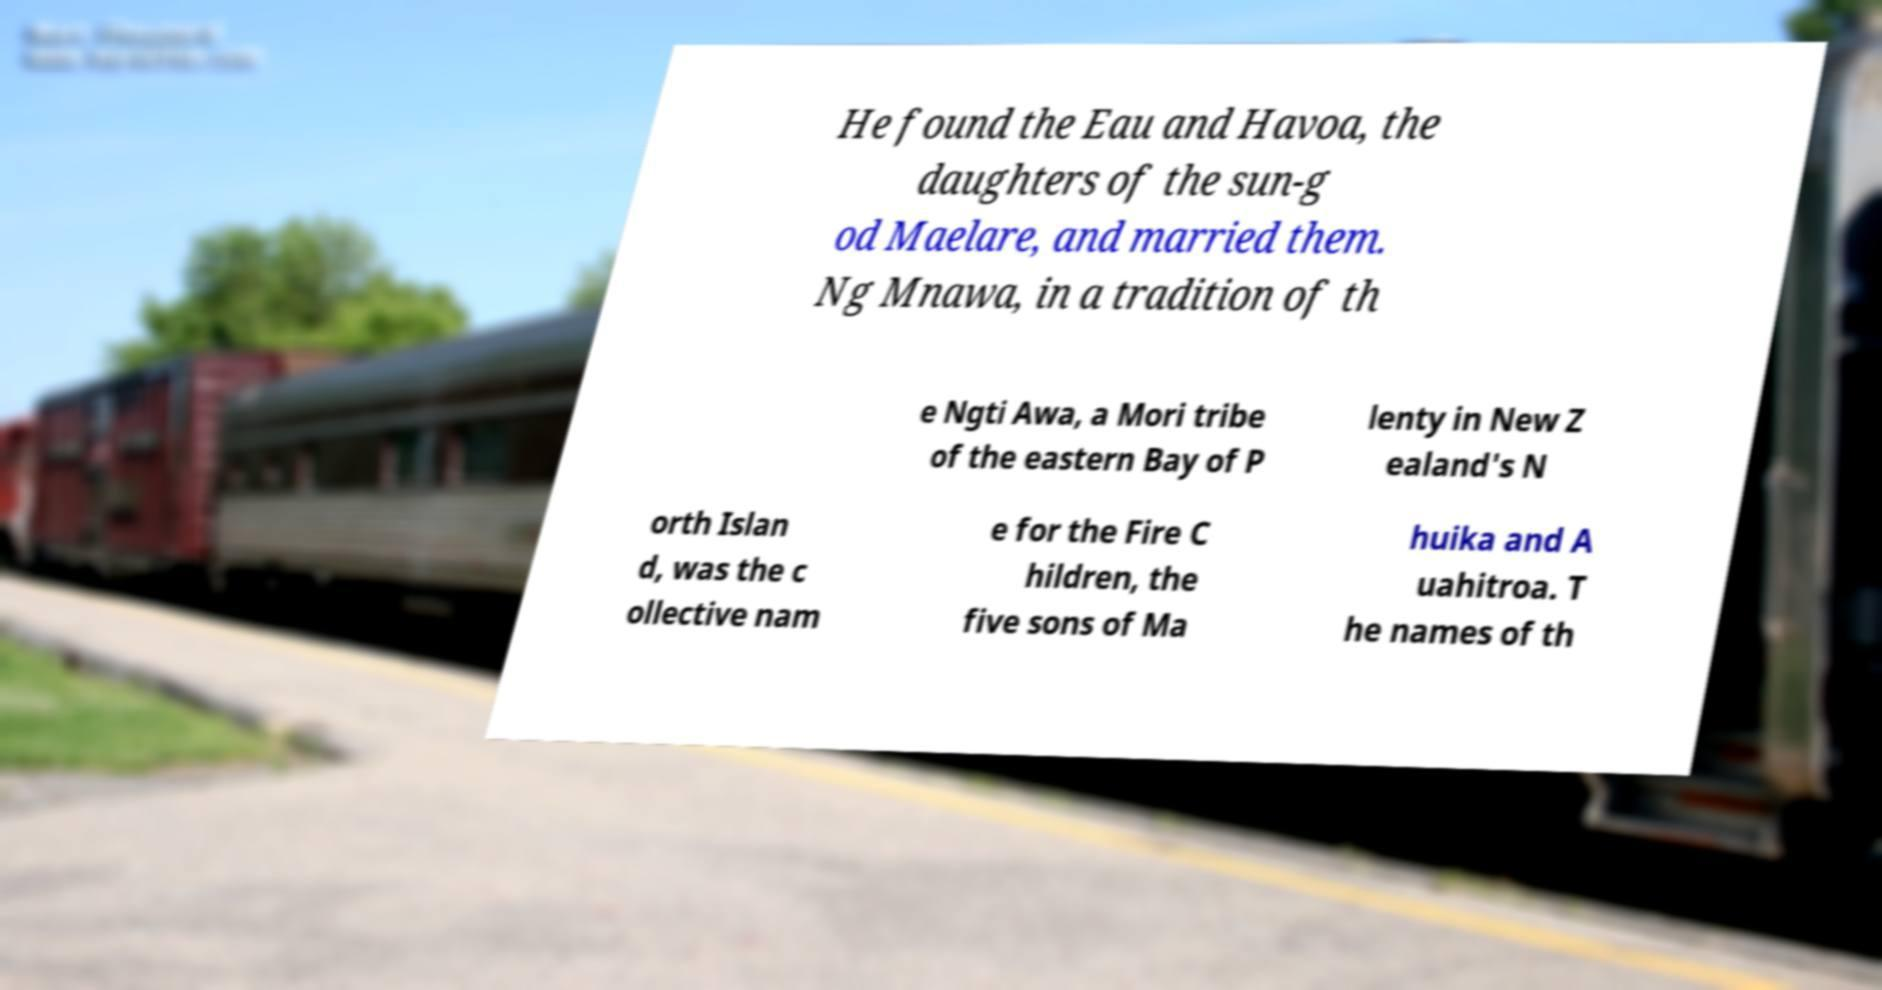Please identify and transcribe the text found in this image. He found the Eau and Havoa, the daughters of the sun-g od Maelare, and married them. Ng Mnawa, in a tradition of th e Ngti Awa, a Mori tribe of the eastern Bay of P lenty in New Z ealand's N orth Islan d, was the c ollective nam e for the Fire C hildren, the five sons of Ma huika and A uahitroa. T he names of th 